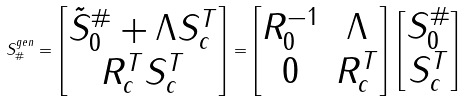<formula> <loc_0><loc_0><loc_500><loc_500>S _ { \# } ^ { g e n } = \left [ \begin{matrix} \tilde { S } _ { 0 } ^ { \# } + \Lambda S _ { c } ^ { T } \\ R _ { c } ^ { T } S _ { c } ^ { T } \end{matrix} \right ] = \left [ \begin{matrix} R _ { 0 } ^ { - 1 } & \Lambda \\ 0 & R _ { c } ^ { T } \end{matrix} \right ] \, \left [ \begin{matrix} S _ { 0 } ^ { \# } \\ S _ { c } ^ { T } \end{matrix} \right ]</formula> 